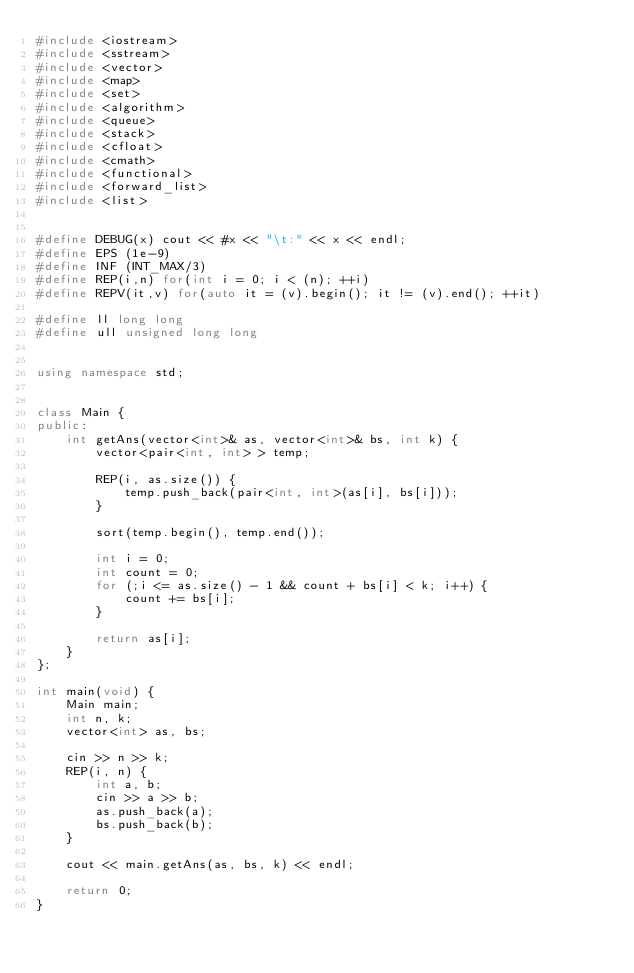Convert code to text. <code><loc_0><loc_0><loc_500><loc_500><_C++_>#include <iostream>
#include <sstream>
#include <vector>
#include <map>
#include <set>
#include <algorithm>
#include <queue>
#include <stack>
#include <cfloat>
#include <cmath>
#include <functional>
#include <forward_list>
#include <list>


#define DEBUG(x) cout << #x << "\t:" << x << endl;
#define EPS (1e-9)
#define INF (INT_MAX/3)
#define REP(i,n) for(int i = 0; i < (n); ++i)
#define REPV(it,v) for(auto it = (v).begin(); it != (v).end(); ++it)

#define ll long long
#define ull unsigned long long


using namespace std;


class Main {
public:
	int getAns(vector<int>& as, vector<int>& bs, int k) {
		vector<pair<int, int> > temp;
		
		REP(i, as.size()) {
			temp.push_back(pair<int, int>(as[i], bs[i]));
		}

		sort(temp.begin(), temp.end());

		int i = 0;
		int count = 0;
		for (;i <= as.size() - 1 && count + bs[i] < k; i++) {
			count += bs[i];
		}

		return as[i];
	}
};

int main(void) {
	Main main;
	int n, k;
	vector<int> as, bs;

	cin >> n >> k;
	REP(i, n) {
		int a, b;
		cin >> a >> b;
		as.push_back(a);
		bs.push_back(b);
	}

	cout << main.getAns(as, bs, k) << endl;
	
	return 0;
}</code> 